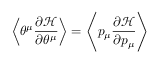Convert formula to latex. <formula><loc_0><loc_0><loc_500><loc_500>\left \langle \theta ^ { \mu } \frac { \partial \mathcal { H } } { \partial \theta ^ { \mu } } \right \rangle = \left \langle p _ { \mu } \frac { \partial \mathcal { H } } { \partial p _ { \mu } } \right \rangle</formula> 